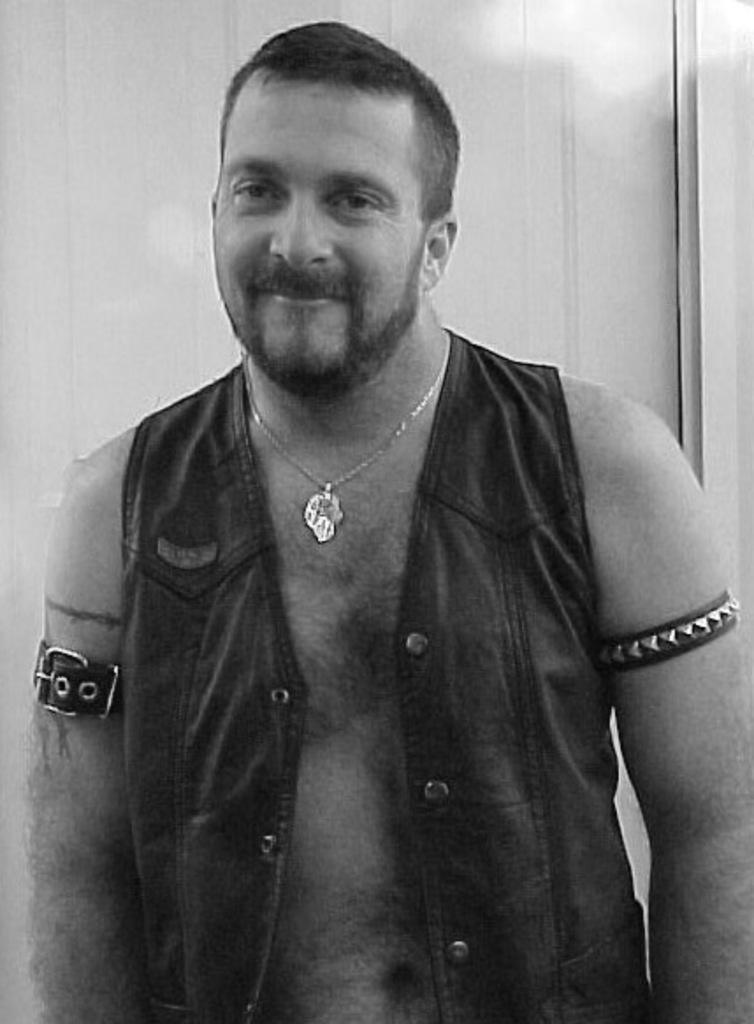Who is the main subject in the image? There is a man in the center of the image. What type of mint can be seen growing near the man in the image? There is no mint present in the image; it only features a man in the center. How many apples is the man holding in the image? There are no apples visible in the image, as it only features a man in the center. What letter is the man holding in the image? There is no letter present in the image; it only features a man in the center. 